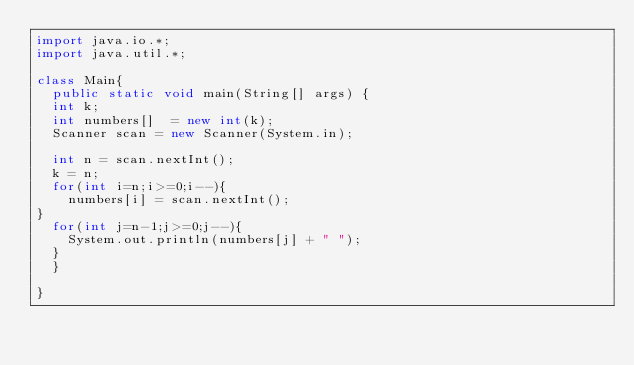<code> <loc_0><loc_0><loc_500><loc_500><_Java_>import java.io.*;
import java.util.*;

class Main{
  public static void main(String[] args) {
  int k;
  int numbers[]  = new int(k);
  Scanner scan = new Scanner(System.in);

  int n = scan.nextInt();
  k = n;
  for(int i=n;i>=0;i--){
    numbers[i] = scan.nextInt();
}
  for(int j=n-1;j>=0;j--){
    System.out.println(numbers[j] + " ");
  }
  }

}</code> 